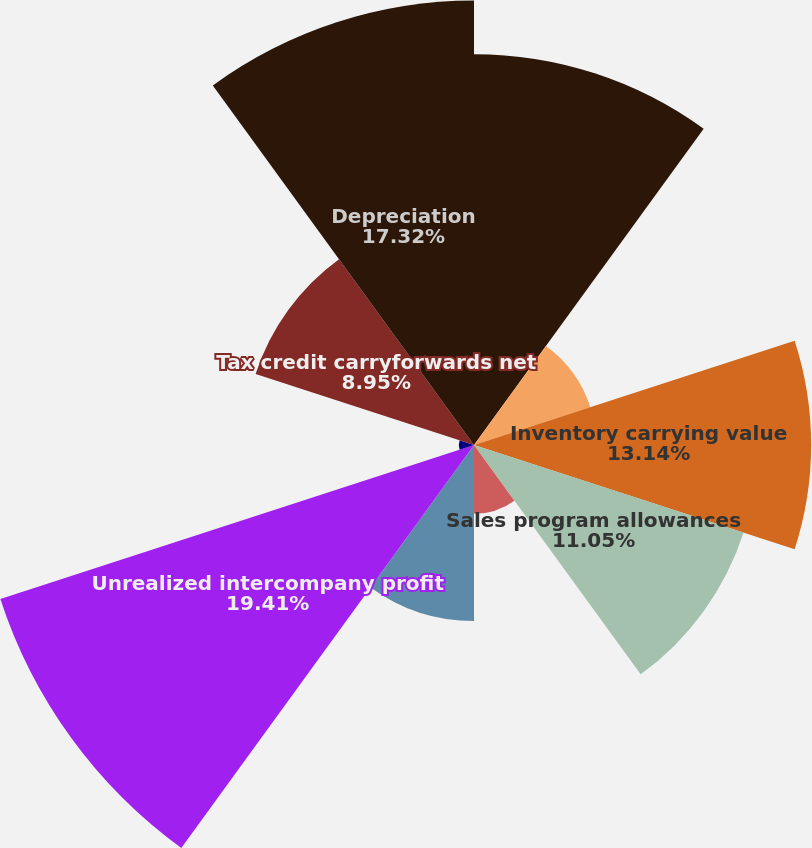Convert chart. <chart><loc_0><loc_0><loc_500><loc_500><pie_chart><fcel>Product warranty accruals<fcel>Allowance for doubtful<fcel>Inventory carrying value<fcel>Sales program allowances<fcel>Reserve for sales returns<fcel>Vacation accrual<fcel>Unrealized intercompany profit<fcel>Unrealized foreign currency<fcel>Tax credit carryforwards net<fcel>Depreciation<nl><fcel>15.23%<fcel>4.77%<fcel>13.14%<fcel>11.05%<fcel>2.68%<fcel>6.86%<fcel>19.41%<fcel>0.59%<fcel>8.95%<fcel>17.32%<nl></chart> 